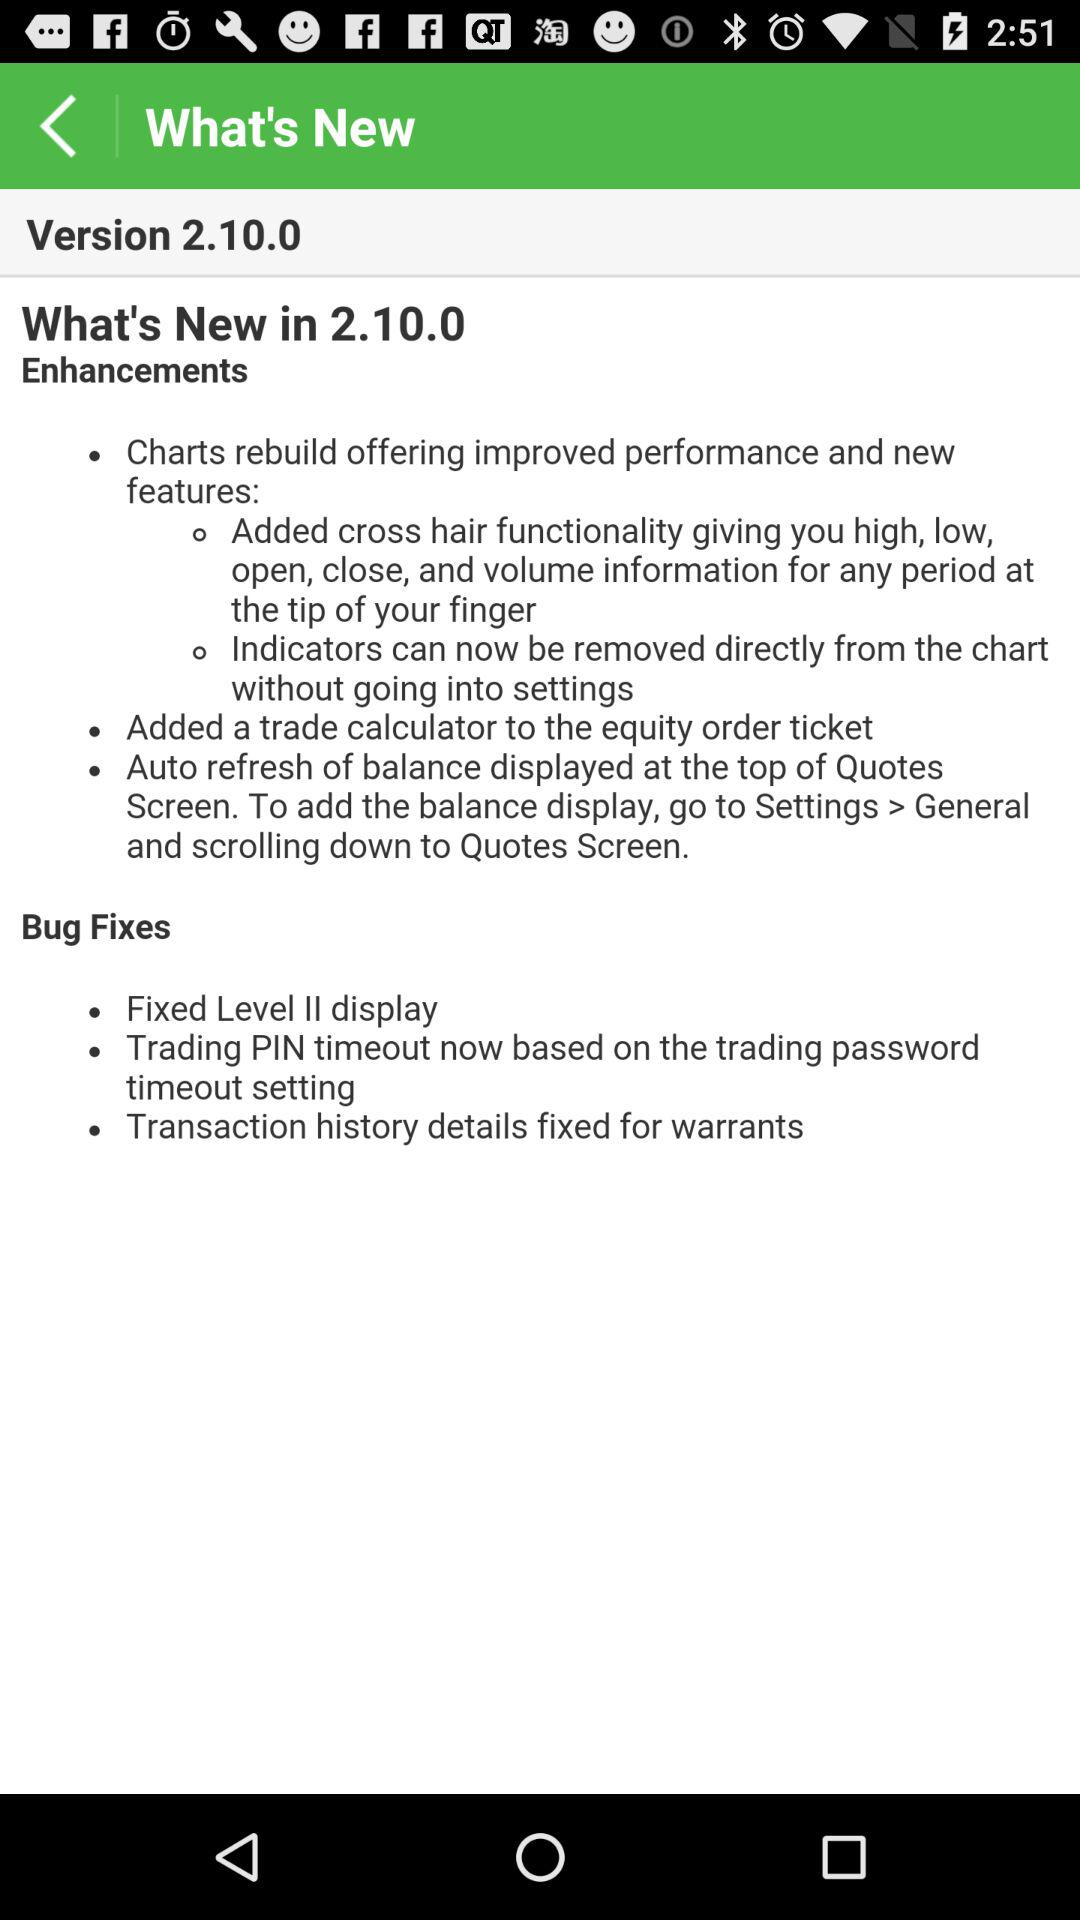What is the version of the application? The version of the application is 2.10.0. 